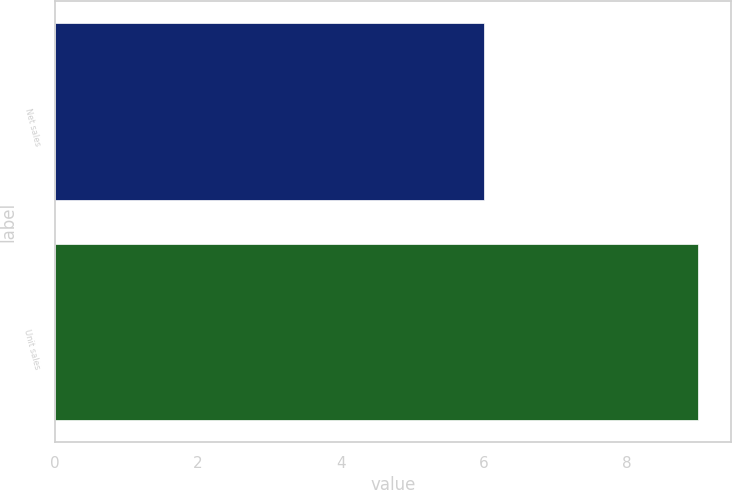Convert chart. <chart><loc_0><loc_0><loc_500><loc_500><bar_chart><fcel>Net sales<fcel>Unit sales<nl><fcel>6<fcel>9<nl></chart> 